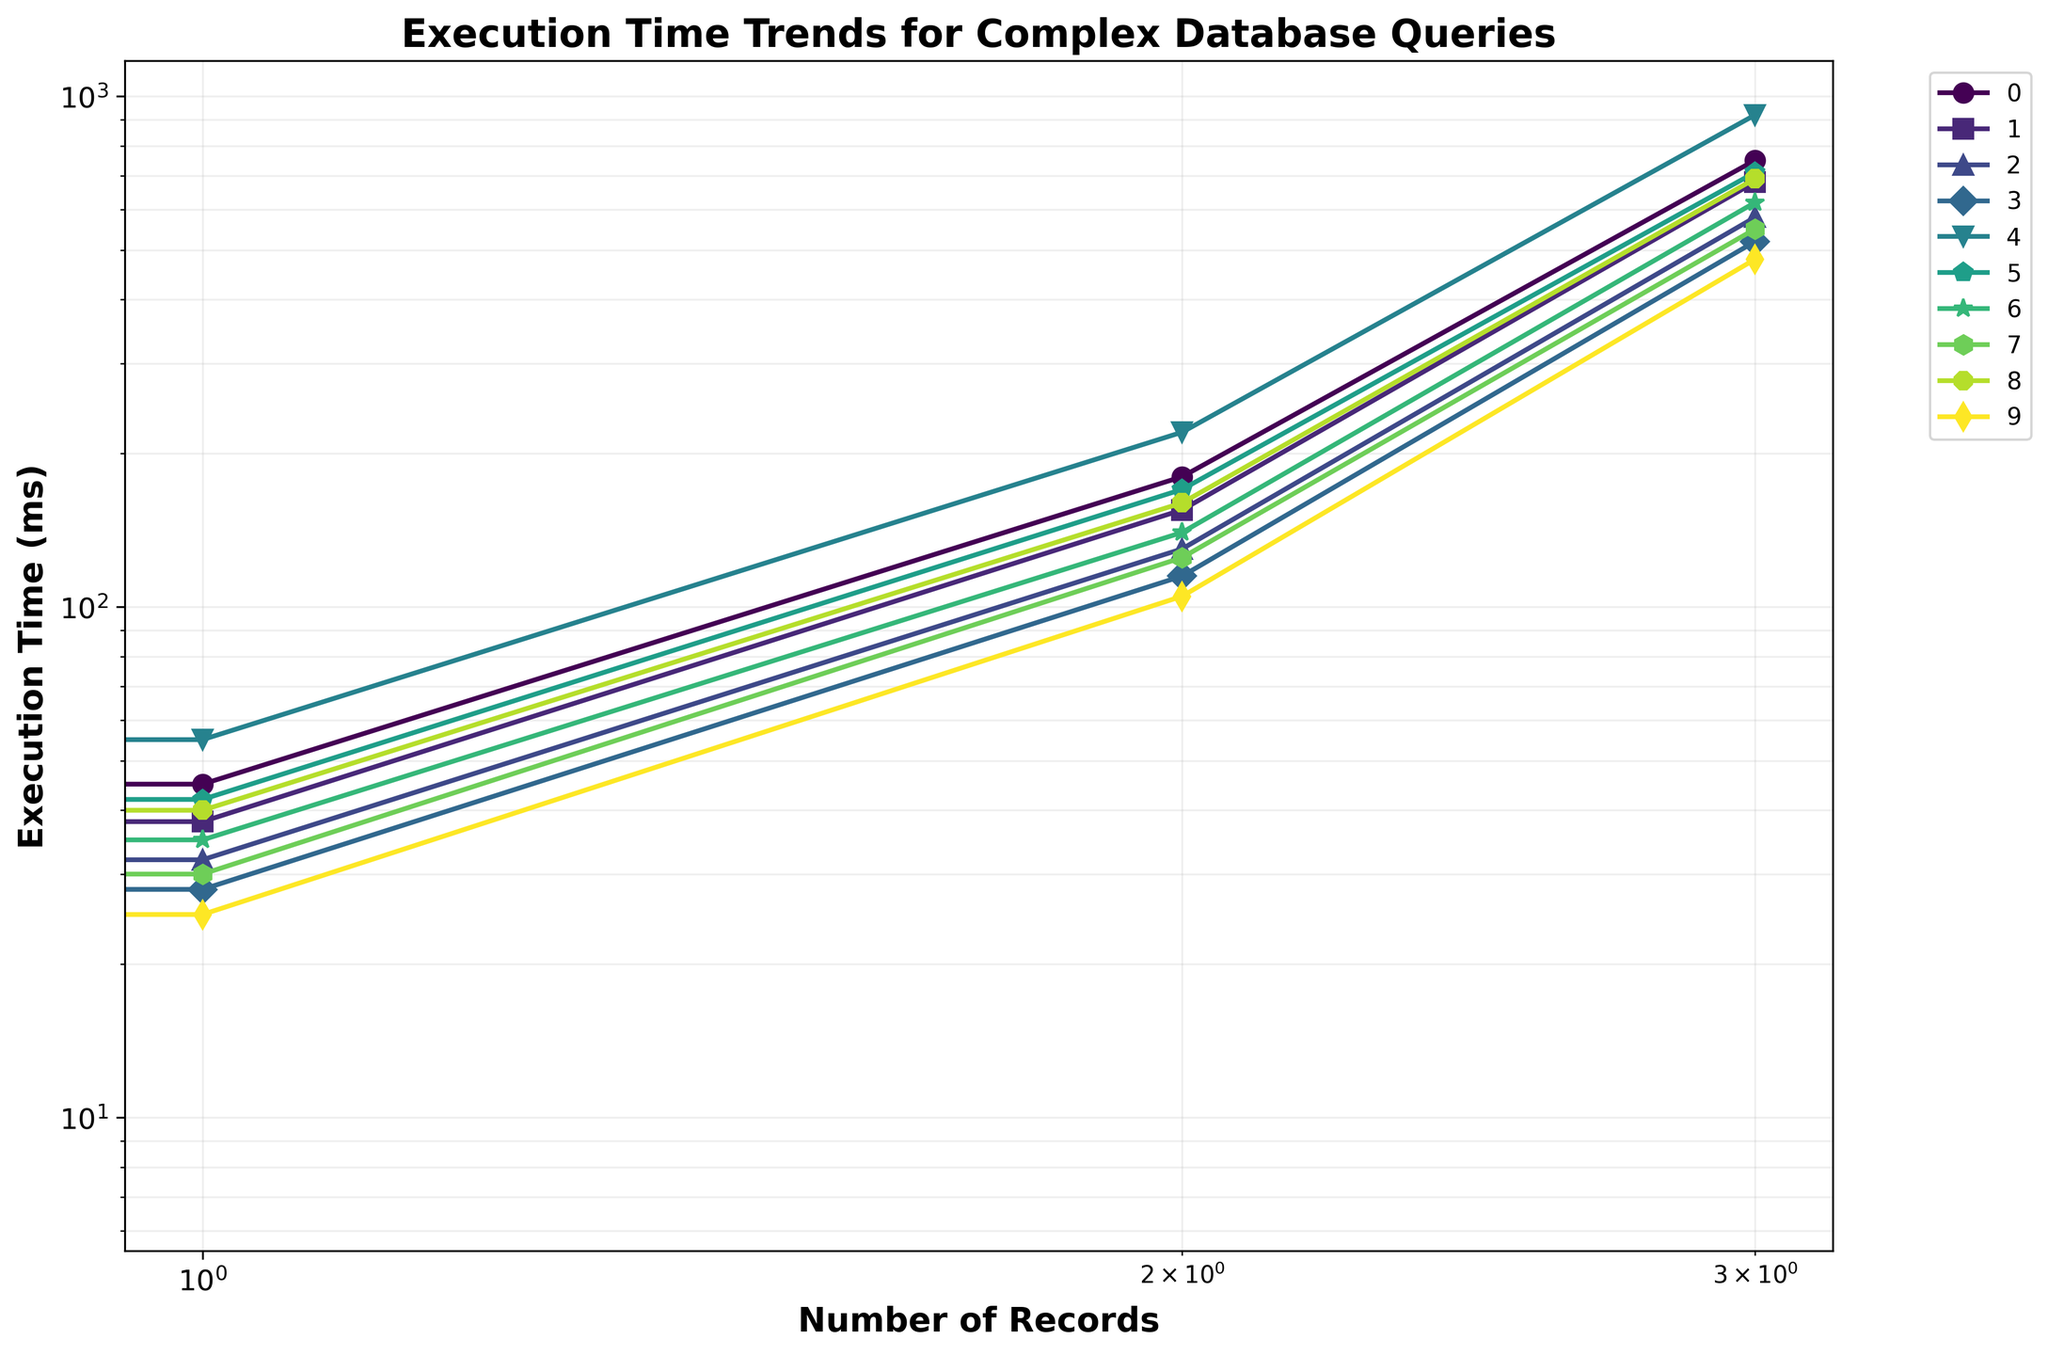Which approach has the lowest execution time for 1,000,000 records? Approach "Compiled Queries" shows an execution time of 480 ms for 1,000,000 records, which is the lowest among all the approaches.
Answer: Compiled Queries Between "Standard Fluent Mapping" and "Dynamic Mapping", which approach performs better for 10,000 records? For 10,000 records, "Standard Fluent Mapping" indicates an execution time of 45 ms, while "Dynamic Mapping" indicates 40 ms. The lower the time, the better the performance. So, “Dynamic Mapping” performs better.
Answer: Dynamic Mapping What is the average execution time for the "Batch Fetching" approach across all record sizes? Summing up the execution times for "Batch Fetching" across 1,000, 10,000, 100,000, and 1,000,000 records gives us 10 + 32 + 130 + 580 = 752 ms. The average time is 752/4 = 188 ms.
Answer: 188 ms Which approach shows an improvement in performance when moving from 1,000 records to 1,000,000 records? All approaches exhibit an increase in execution time as the number of records increases. To detect an "improvement", we need to compare the rate of increase. Fewest jump is shown by “Query Projections” with values rising from 8 ms to 520 ms (a smaller factor in comparison to "Lazy Loading" jumping from 18 ms to 920 ms).
Answer: None (all increase) What is the difference in execution times between "Lazy Loading" and "Eager Loading" for 100,000 records? "Lazy Loading" has an execution time of 220 ms for 100,000 records, while "Eager Loading" has 170 ms. The difference is 220 - 170 = 50 ms.
Answer: 50 ms Which approach has the highest execution time for 10,000 records and what is the value? "Lazy Loading" has the highest execution time for 10,000 records at 55 ms, compared to other approaches.
Answer: Lazy Loading, 55 ms Do any approaches have equal execution times for any specific record sizes? Comparing values across all record sizes, there are no identical execution times between different approaches for any specific record size.
Answer: No How does the execution time for "Future Queries" change from 1,000 to 1,000,000 records? Execution times for "Future Queries" range from 9 ms at 1,000 records, increasing incrementally to 30 ms, 125 ms, and ultimately 550 ms at 1,000,000 records. This shows a substantial increase as record size grows.
Answer: Increases For record size 10,000, which approach has a closer execution time to the “Customized Conventions” approach? "Customized Conventions" has an execution time of 38 ms for 10,000 records. The closest value is from "Dynamic Mapping" with 40 ms (only a 2 ms difference).
Answer: Dynamic Mapping What is the sum of execution times for "Query Projections" for 1,000 and 10,000 records? The "Query Projections" approach has execution times of 8 ms for 1,000 records and 28 ms for 10,000 records. Summing these gives 8 + 28 = 36 ms.
Answer: 36 ms 